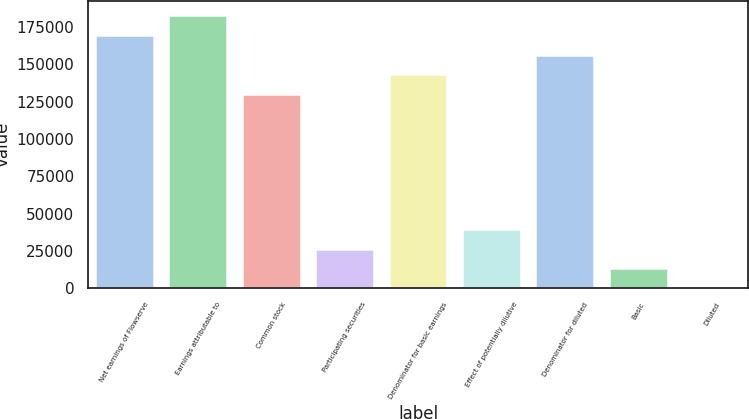Convert chart to OTSL. <chart><loc_0><loc_0><loc_500><loc_500><bar_chart><fcel>Net earnings of Flowserve<fcel>Earnings attributable to<fcel>Common stock<fcel>Participating securities<fcel>Denominator for basic earnings<fcel>Effect of potentially dilutive<fcel>Denominator for diluted<fcel>Basic<fcel>Diluted<nl><fcel>169885<fcel>183131<fcel>130147<fcel>26493<fcel>143393<fcel>39739<fcel>156639<fcel>13247<fcel>1.01<nl></chart> 